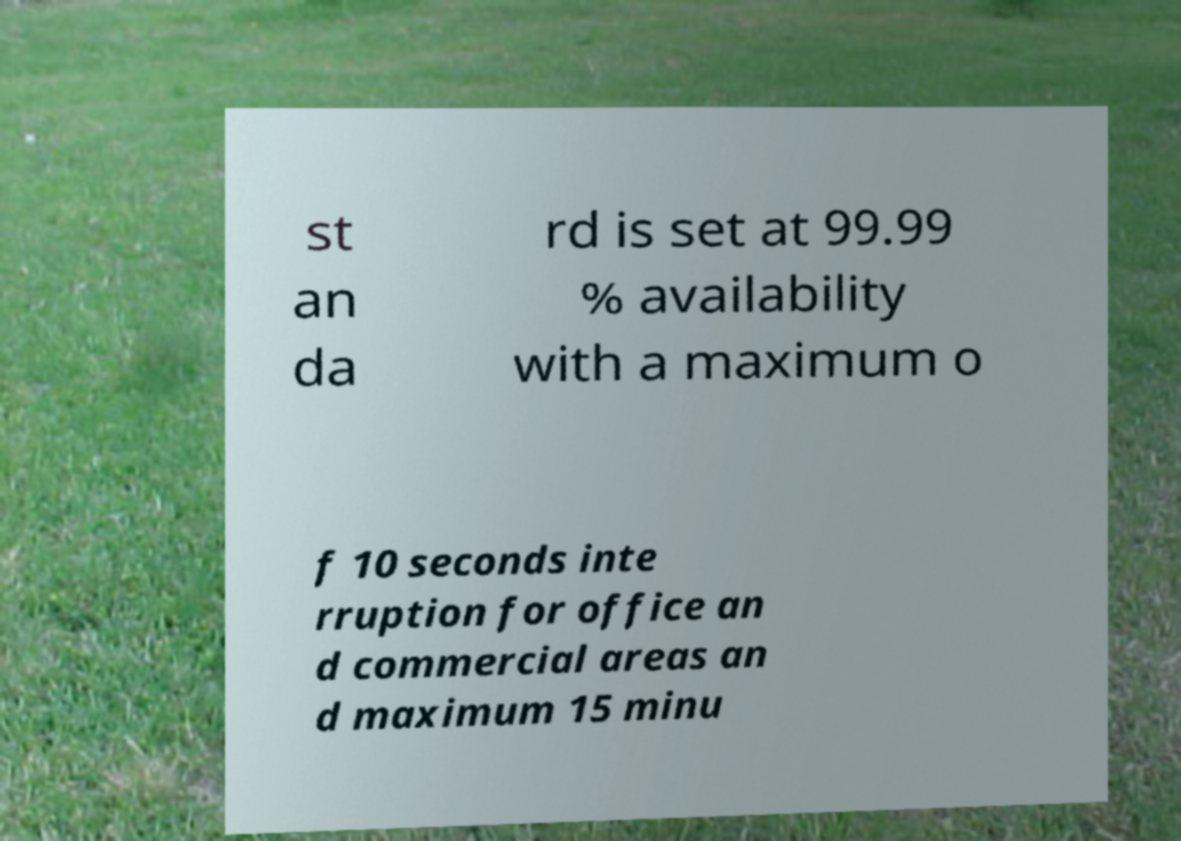Can you read and provide the text displayed in the image?This photo seems to have some interesting text. Can you extract and type it out for me? st an da rd is set at 99.99 % availability with a maximum o f 10 seconds inte rruption for office an d commercial areas an d maximum 15 minu 